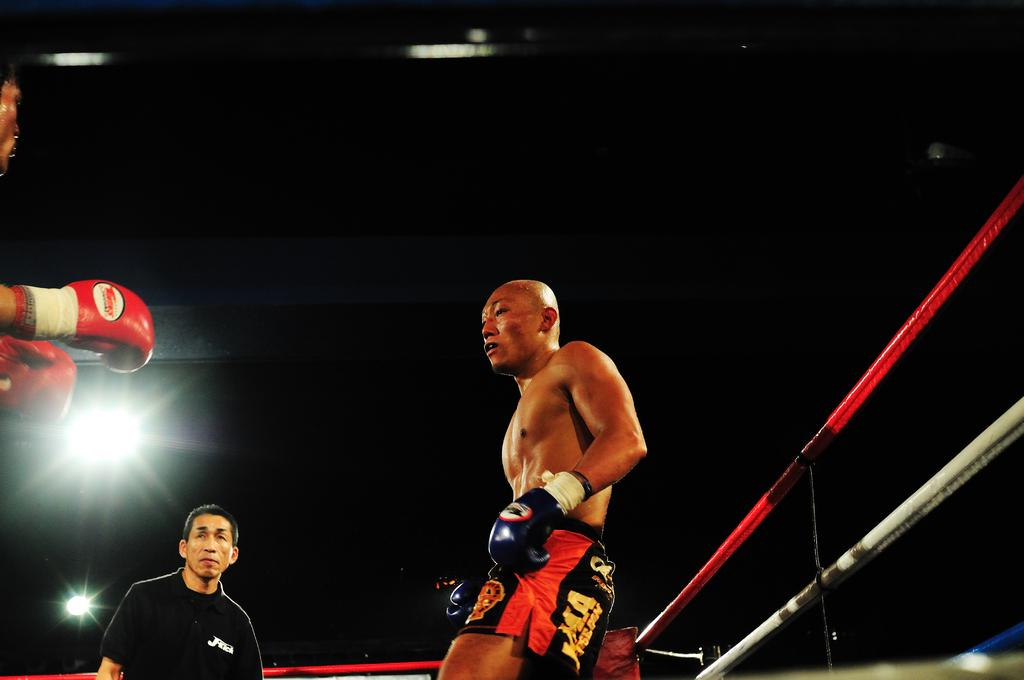<image>
Describe the image concisely. Boxer in a ring wearing shorts that has the letter A on it. 